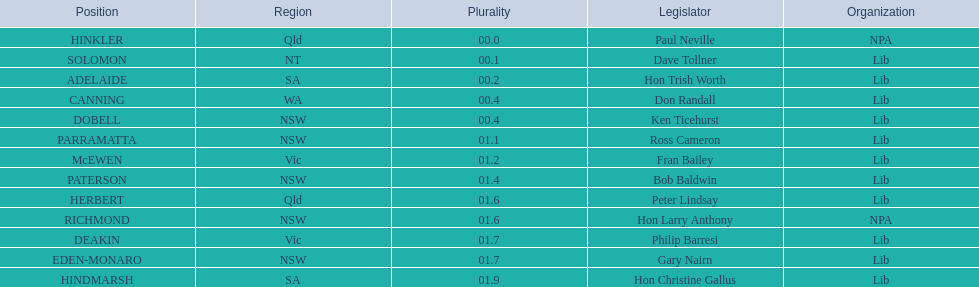Who are all the lib party members? Dave Tollner, Hon Trish Worth, Don Randall, Ken Ticehurst, Ross Cameron, Fran Bailey, Bob Baldwin, Peter Lindsay, Philip Barresi, Gary Nairn, Hon Christine Gallus. What lib party members are in sa? Hon Trish Worth, Hon Christine Gallus. What is the highest difference in majority between members in sa? 01.9. 